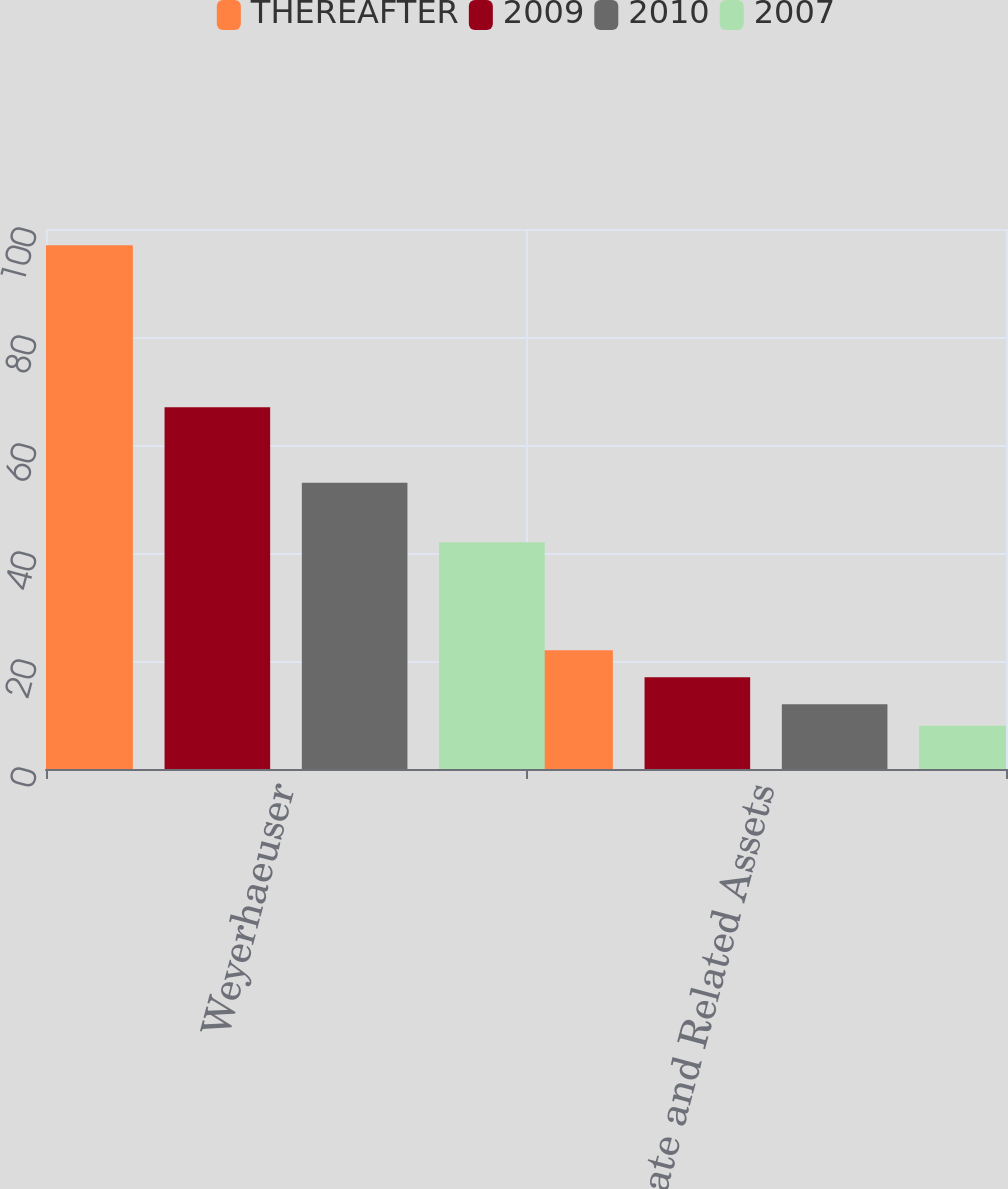Convert chart. <chart><loc_0><loc_0><loc_500><loc_500><stacked_bar_chart><ecel><fcel>Weyerhaeuser<fcel>Real Estate and Related Assets<nl><fcel>THEREAFTER<fcel>97<fcel>22<nl><fcel>2009<fcel>67<fcel>17<nl><fcel>2010<fcel>53<fcel>12<nl><fcel>2007<fcel>42<fcel>8<nl></chart> 